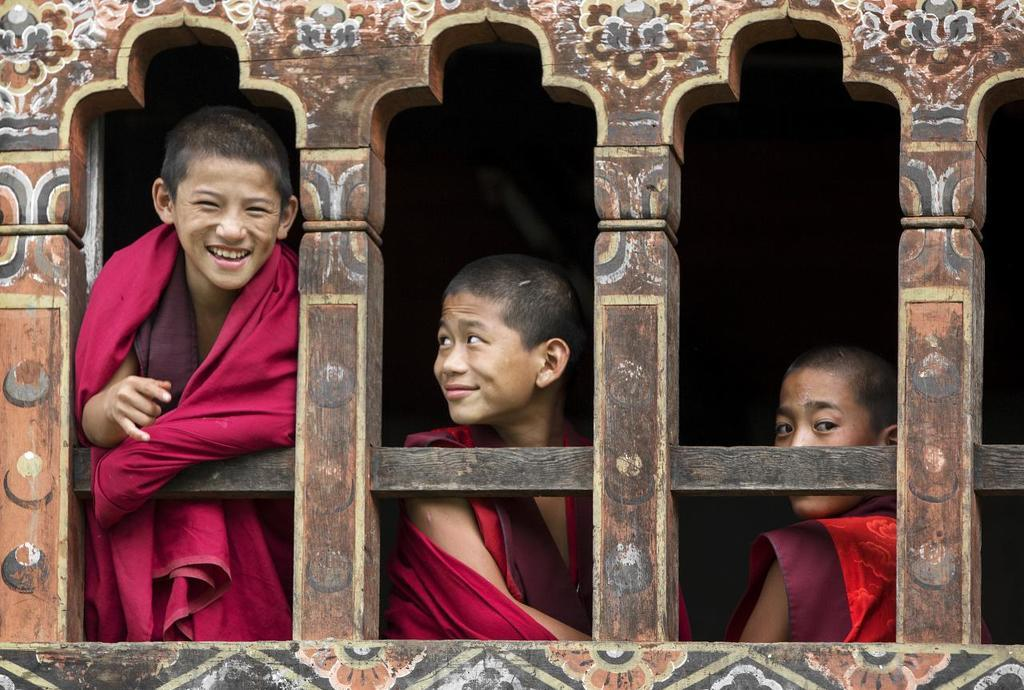How many people are in the image? There are three boys in the image. What can be seen in the image besides the boys? There are windows visible in the image. What is the color of the background in the image? The background of the image is dark. What type of dolls can be seen playing with fairies in the image? There are no dolls or fairies present in the image; it features three boys and windows. What is the nationality of the boys in the image? The nationality of the boys cannot be determined from the image alone. 